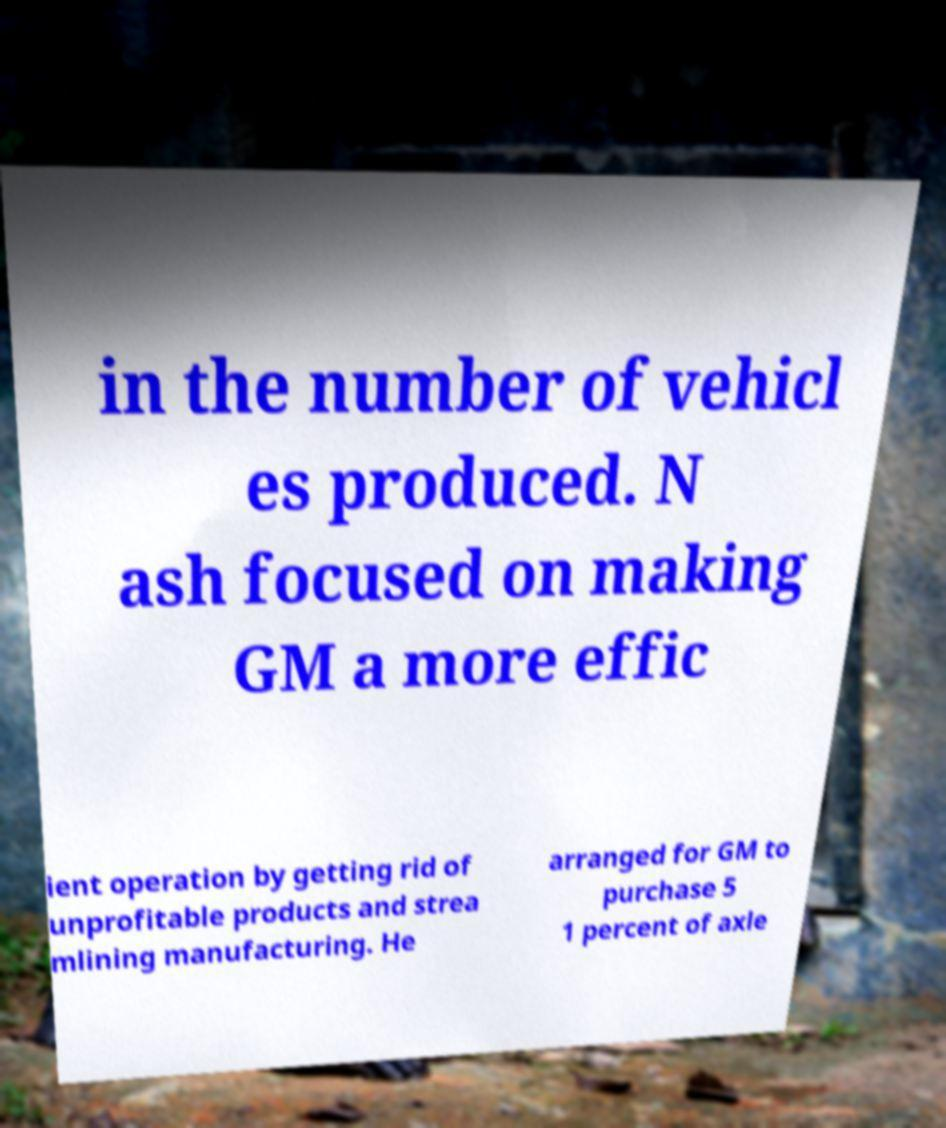Could you extract and type out the text from this image? in the number of vehicl es produced. N ash focused on making GM a more effic ient operation by getting rid of unprofitable products and strea mlining manufacturing. He arranged for GM to purchase 5 1 percent of axle 